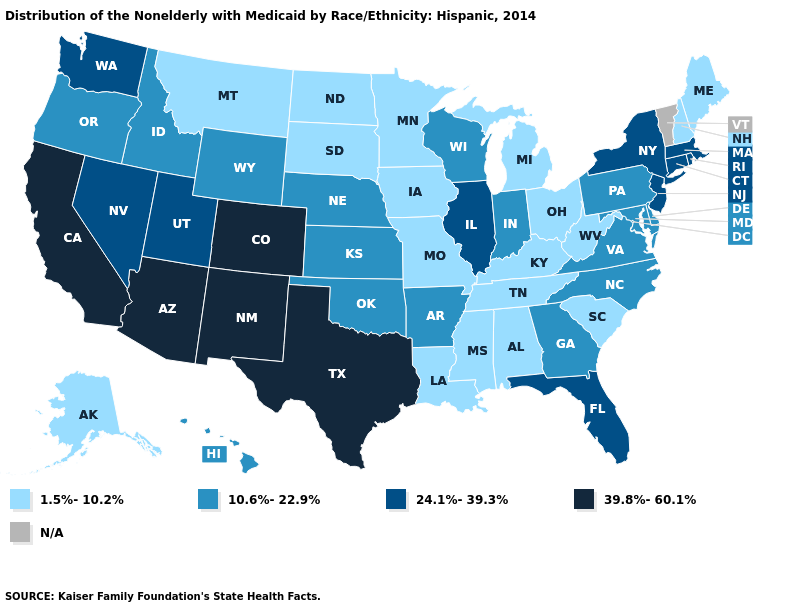Name the states that have a value in the range 1.5%-10.2%?
Concise answer only. Alabama, Alaska, Iowa, Kentucky, Louisiana, Maine, Michigan, Minnesota, Mississippi, Missouri, Montana, New Hampshire, North Dakota, Ohio, South Carolina, South Dakota, Tennessee, West Virginia. Name the states that have a value in the range 39.8%-60.1%?
Short answer required. Arizona, California, Colorado, New Mexico, Texas. What is the value of Hawaii?
Concise answer only. 10.6%-22.9%. What is the lowest value in states that border Mississippi?
Give a very brief answer. 1.5%-10.2%. Among the states that border New Jersey , does Delaware have the lowest value?
Concise answer only. Yes. Does Pennsylvania have the highest value in the Northeast?
Quick response, please. No. What is the highest value in the Northeast ?
Concise answer only. 24.1%-39.3%. Name the states that have a value in the range 39.8%-60.1%?
Write a very short answer. Arizona, California, Colorado, New Mexico, Texas. Name the states that have a value in the range 39.8%-60.1%?
Concise answer only. Arizona, California, Colorado, New Mexico, Texas. What is the value of Arizona?
Quick response, please. 39.8%-60.1%. What is the value of West Virginia?
Give a very brief answer. 1.5%-10.2%. What is the value of Michigan?
Be succinct. 1.5%-10.2%. What is the highest value in the USA?
Answer briefly. 39.8%-60.1%. 